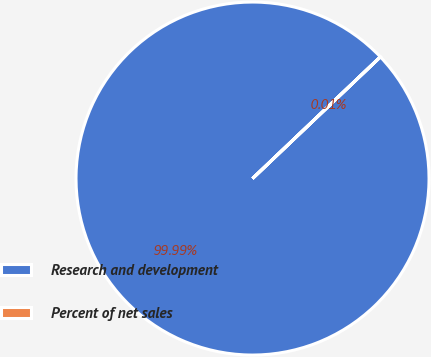<chart> <loc_0><loc_0><loc_500><loc_500><pie_chart><fcel>Research and development<fcel>Percent of net sales<nl><fcel>99.99%<fcel>0.01%<nl></chart> 